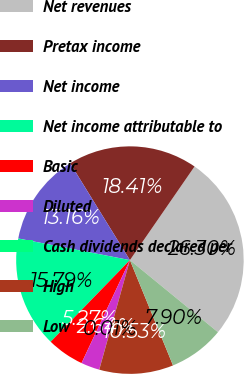Convert chart to OTSL. <chart><loc_0><loc_0><loc_500><loc_500><pie_chart><fcel>Net revenues<fcel>Pretax income<fcel>Net income<fcel>Net income attributable to<fcel>Basic<fcel>Diluted<fcel>Cash dividends declared per<fcel>High<fcel>Low<nl><fcel>26.31%<fcel>18.42%<fcel>13.16%<fcel>15.79%<fcel>5.27%<fcel>2.64%<fcel>0.01%<fcel>10.53%<fcel>7.9%<nl></chart> 